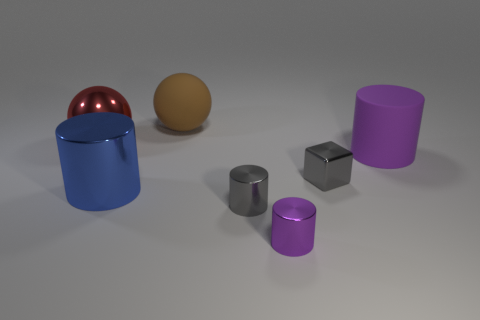Is the number of big blue metal cylinders greater than the number of tiny gray matte objects?
Your answer should be very brief. Yes. There is a big object that is on the right side of the brown matte thing; does it have the same shape as the brown rubber thing?
Give a very brief answer. No. Is the number of metallic cylinders less than the number of objects?
Ensure brevity in your answer.  Yes. What material is the purple cylinder that is the same size as the metal cube?
Ensure brevity in your answer.  Metal. There is a small cube; is it the same color as the small cylinder left of the purple metal cylinder?
Make the answer very short. Yes. Are there fewer blocks on the left side of the tiny purple cylinder than tiny red rubber cubes?
Your answer should be compact. No. How many cylinders are there?
Provide a short and direct response. 4. There is a small gray object that is in front of the big thing in front of the large matte cylinder; what shape is it?
Offer a very short reply. Cylinder. What number of cylinders are to the right of the shiny block?
Make the answer very short. 1. Is the small gray cube made of the same material as the purple cylinder that is behind the metal cube?
Give a very brief answer. No. 